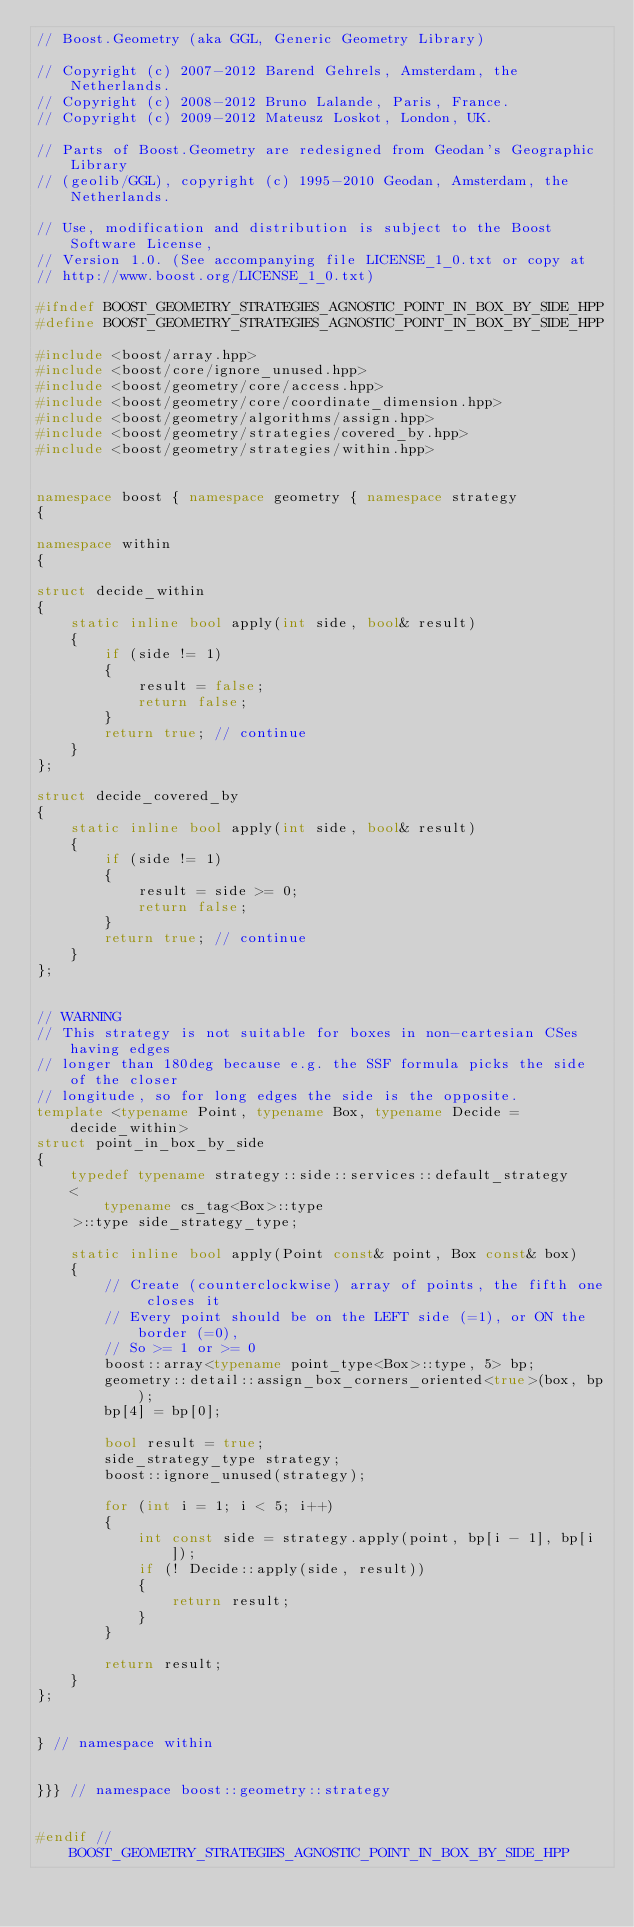Convert code to text. <code><loc_0><loc_0><loc_500><loc_500><_C++_>// Boost.Geometry (aka GGL, Generic Geometry Library)

// Copyright (c) 2007-2012 Barend Gehrels, Amsterdam, the Netherlands.
// Copyright (c) 2008-2012 Bruno Lalande, Paris, France.
// Copyright (c) 2009-2012 Mateusz Loskot, London, UK.

// Parts of Boost.Geometry are redesigned from Geodan's Geographic Library
// (geolib/GGL), copyright (c) 1995-2010 Geodan, Amsterdam, the Netherlands.

// Use, modification and distribution is subject to the Boost Software License,
// Version 1.0. (See accompanying file LICENSE_1_0.txt or copy at
// http://www.boost.org/LICENSE_1_0.txt)

#ifndef BOOST_GEOMETRY_STRATEGIES_AGNOSTIC_POINT_IN_BOX_BY_SIDE_HPP
#define BOOST_GEOMETRY_STRATEGIES_AGNOSTIC_POINT_IN_BOX_BY_SIDE_HPP

#include <boost/array.hpp>
#include <boost/core/ignore_unused.hpp>
#include <boost/geometry/core/access.hpp>
#include <boost/geometry/core/coordinate_dimension.hpp>
#include <boost/geometry/algorithms/assign.hpp>
#include <boost/geometry/strategies/covered_by.hpp>
#include <boost/geometry/strategies/within.hpp>


namespace boost { namespace geometry { namespace strategy
{

namespace within
{

struct decide_within
{
    static inline bool apply(int side, bool& result)
    {
        if (side != 1)
        {
            result = false;
            return false;
        }
        return true; // continue
    }
};

struct decide_covered_by
{
    static inline bool apply(int side, bool& result)
    {
        if (side != 1)
        {
            result = side >= 0;
            return false;
        }
        return true; // continue
    }
};


// WARNING
// This strategy is not suitable for boxes in non-cartesian CSes having edges
// longer than 180deg because e.g. the SSF formula picks the side of the closer
// longitude, so for long edges the side is the opposite.
template <typename Point, typename Box, typename Decide = decide_within>
struct point_in_box_by_side
{
    typedef typename strategy::side::services::default_strategy
    <
        typename cs_tag<Box>::type
    >::type side_strategy_type;

    static inline bool apply(Point const& point, Box const& box)
    {
        // Create (counterclockwise) array of points, the fifth one closes it
        // Every point should be on the LEFT side (=1), or ON the border (=0),
        // So >= 1 or >= 0
        boost::array<typename point_type<Box>::type, 5> bp;
        geometry::detail::assign_box_corners_oriented<true>(box, bp);
        bp[4] = bp[0];

        bool result = true;
        side_strategy_type strategy;
        boost::ignore_unused(strategy);

        for (int i = 1; i < 5; i++)
        {
            int const side = strategy.apply(point, bp[i - 1], bp[i]);
            if (! Decide::apply(side, result))
            {
                return result;
            }
        }

        return result;
    }
};


} // namespace within


}}} // namespace boost::geometry::strategy


#endif // BOOST_GEOMETRY_STRATEGIES_AGNOSTIC_POINT_IN_BOX_BY_SIDE_HPP
</code> 